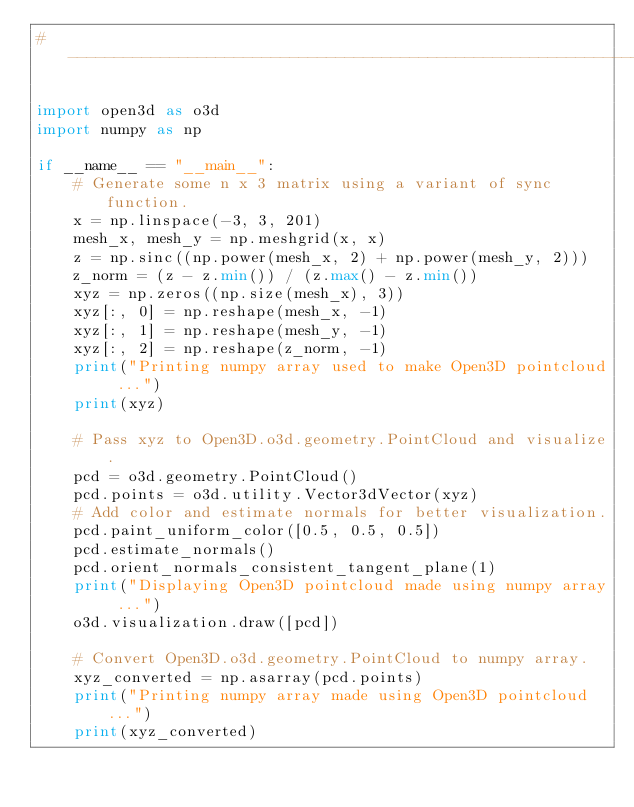Convert code to text. <code><loc_0><loc_0><loc_500><loc_500><_Python_># ----------------------------------------------------------------------------

import open3d as o3d
import numpy as np

if __name__ == "__main__":
    # Generate some n x 3 matrix using a variant of sync function.
    x = np.linspace(-3, 3, 201)
    mesh_x, mesh_y = np.meshgrid(x, x)
    z = np.sinc((np.power(mesh_x, 2) + np.power(mesh_y, 2)))
    z_norm = (z - z.min()) / (z.max() - z.min())
    xyz = np.zeros((np.size(mesh_x), 3))
    xyz[:, 0] = np.reshape(mesh_x, -1)
    xyz[:, 1] = np.reshape(mesh_y, -1)
    xyz[:, 2] = np.reshape(z_norm, -1)
    print("Printing numpy array used to make Open3D pointcloud ...")
    print(xyz)

    # Pass xyz to Open3D.o3d.geometry.PointCloud and visualize.
    pcd = o3d.geometry.PointCloud()
    pcd.points = o3d.utility.Vector3dVector(xyz)
    # Add color and estimate normals for better visualization.
    pcd.paint_uniform_color([0.5, 0.5, 0.5])
    pcd.estimate_normals()
    pcd.orient_normals_consistent_tangent_plane(1)
    print("Displaying Open3D pointcloud made using numpy array ...")
    o3d.visualization.draw([pcd])

    # Convert Open3D.o3d.geometry.PointCloud to numpy array.
    xyz_converted = np.asarray(pcd.points)
    print("Printing numpy array made using Open3D pointcloud ...")
    print(xyz_converted)
</code> 